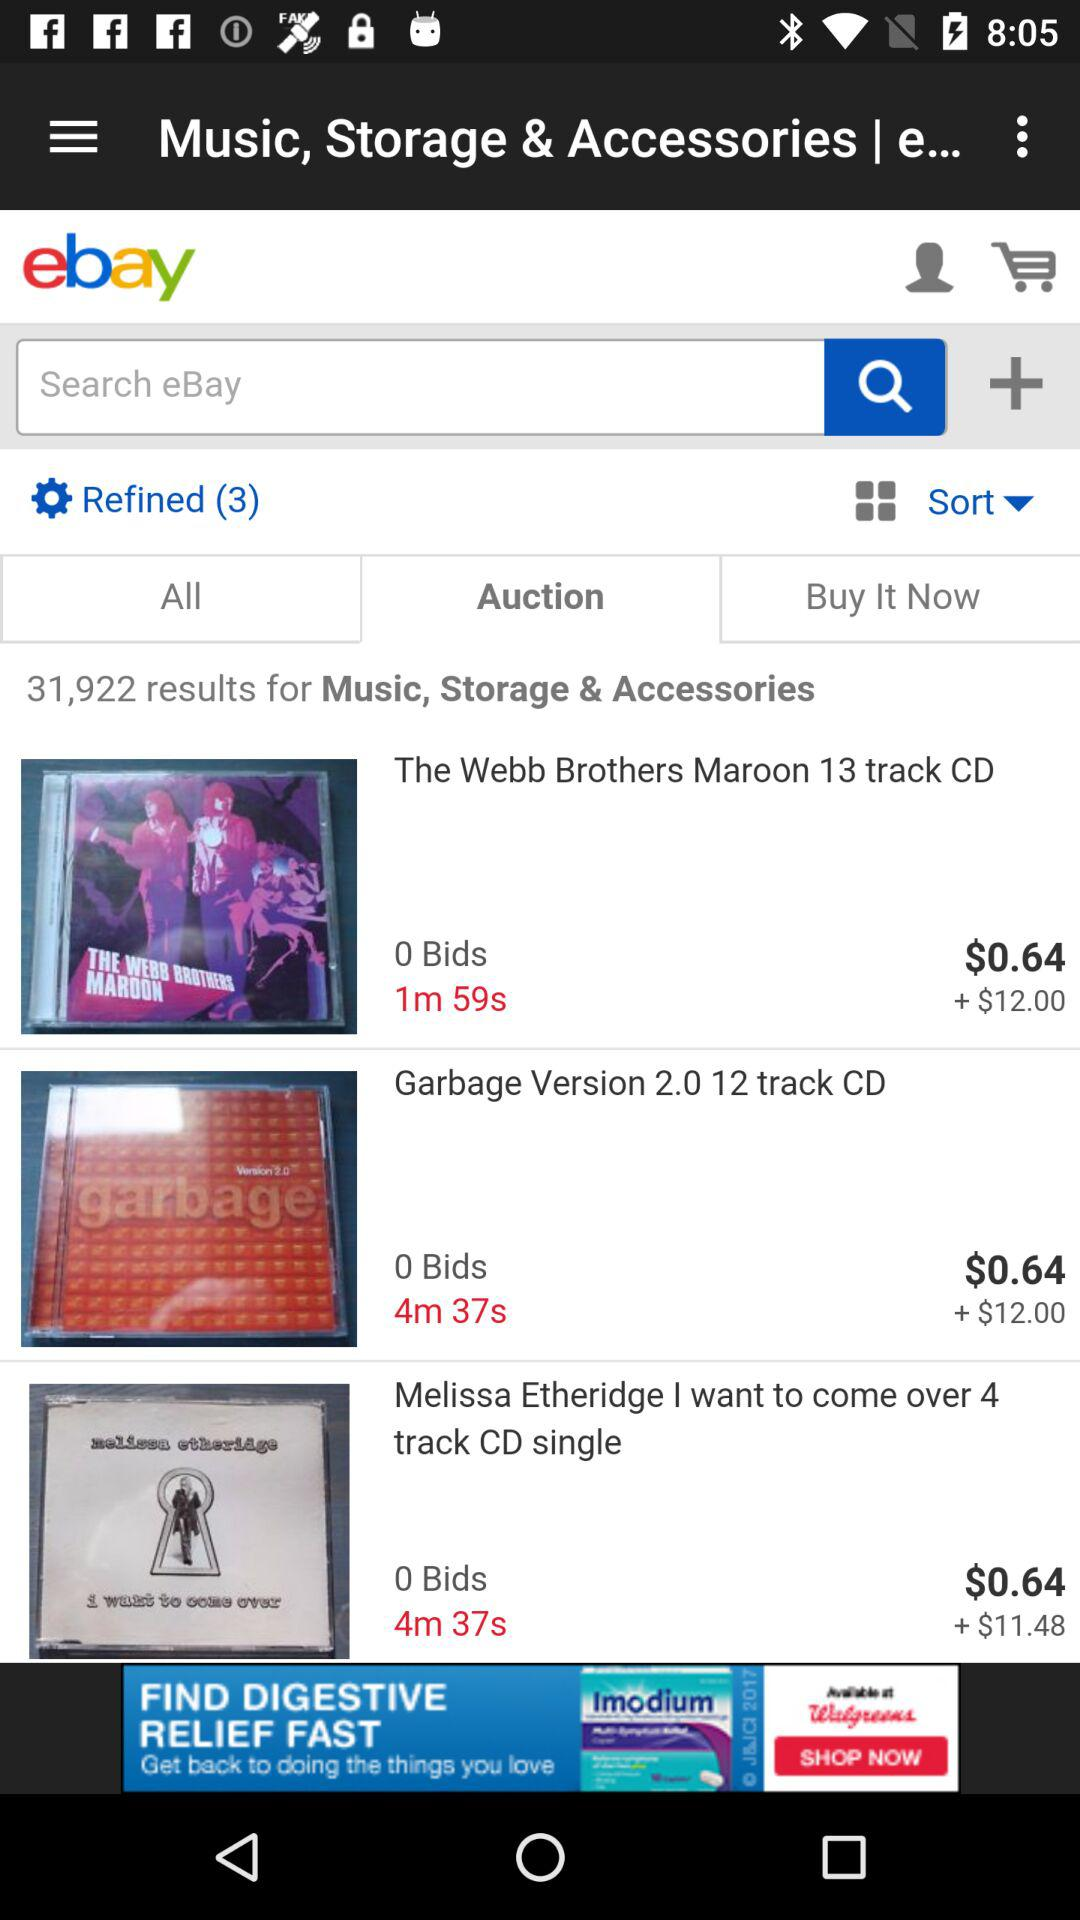What is the cost of the webb brothers maroon 13 track CD?
When the provided information is insufficient, respond with <no answer>. <no answer> 